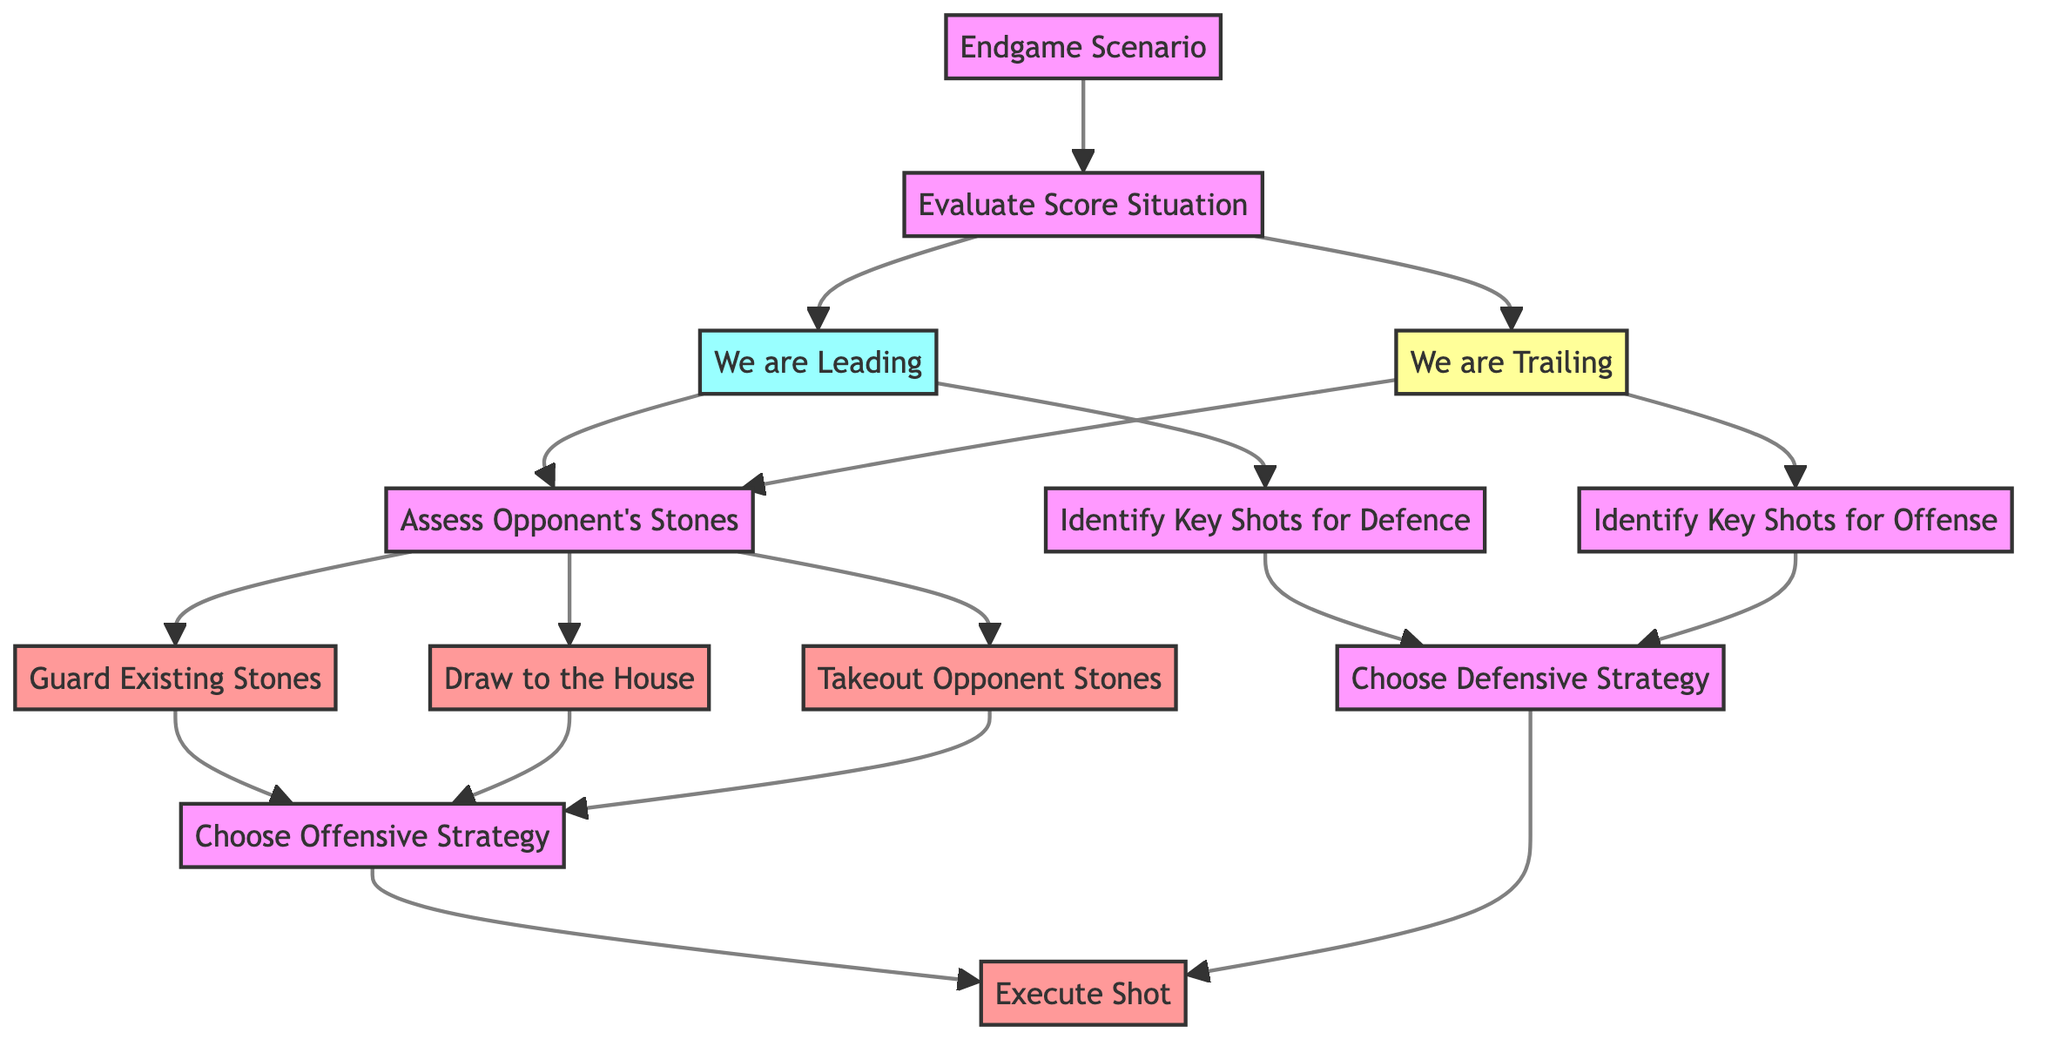What is the total number of nodes in the diagram? The diagram has a total of 13 nodes as indicated in the provided data.
Answer: 13 What is the first step in the decision-making process? The first step is "Evaluate Score Situation," which is the first node connected to the "Endgame Scenario."
Answer: Evaluate Score Situation What happens if "We are Leading"? If "We are Leading," we assess the opponent's stones, which leads to further options such as guarding existing stones or drawing to the house.
Answer: Assess Opponent's Stones How many strategies are there to choose after assessing the opponent's stones? There are three options: Guard Existing Stones, Draw to the House, and Takeout Opponent Stones, leading to choosing an offensive strategy.
Answer: Three What is the outcome of choosing the defensive strategy? Choosing the defensive strategy also leads to executing a shot, as indicated by the directed connections in the diagram.
Answer: Execute Shot Which node connects "We are Trailing" and "Identify Key Shots for Offense"? The node that connects these two is "Assess Opponent's Stones," which is a shared action for both scenarios in the diagram.
Answer: Assess Opponent's Stones What are the last two steps in both the offensive and defensive strategies? The last two steps in both strategies are "Choose Offensive Strategy" and "Execute Shot," as they both lead to the same final action.
Answer: Choose Offensive Strategy, Execute Shot How many edges connect the nodes under "Assess Opponent's Stones"? There are three edges connecting the nodes under "Assess Opponent's Stones," leading to Guard Existing Stones, Draw to the House, and Takeout Opponent Stones.
Answer: Three What is the relationship between "We are Leading" and "Identify Key Shots for Defence"? The relationship is that "We are Leading" directly leads to assessing opponent's stones and subsequently allows for identifying key shots for defense.
Answer: Assess Opponent's Stones 